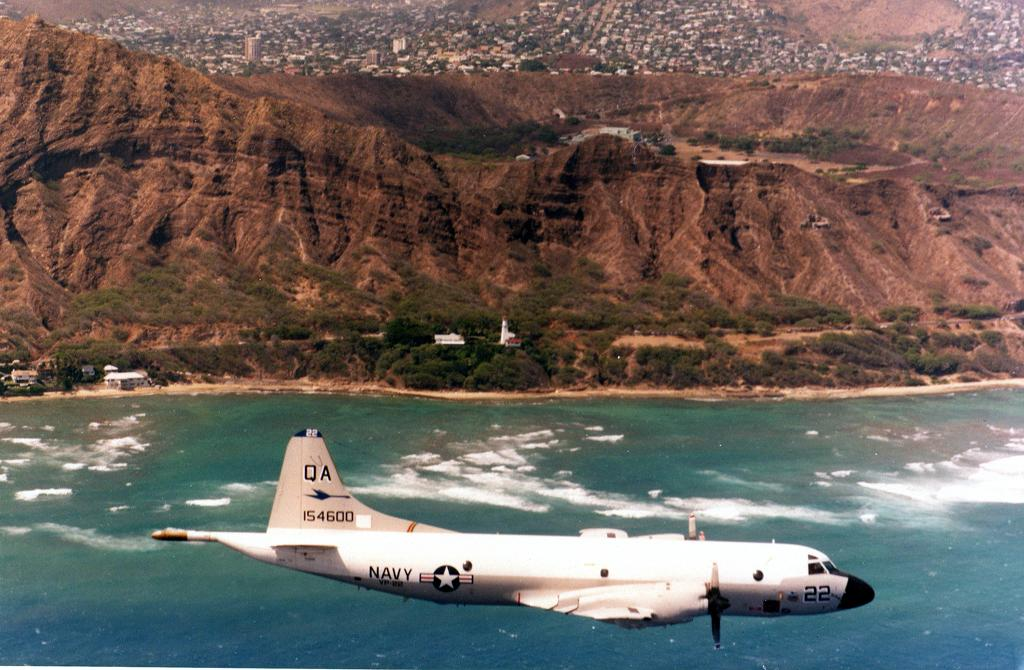Provide a one-sentence caption for the provided image. a plane flying over a ocean operated by the Navy. 